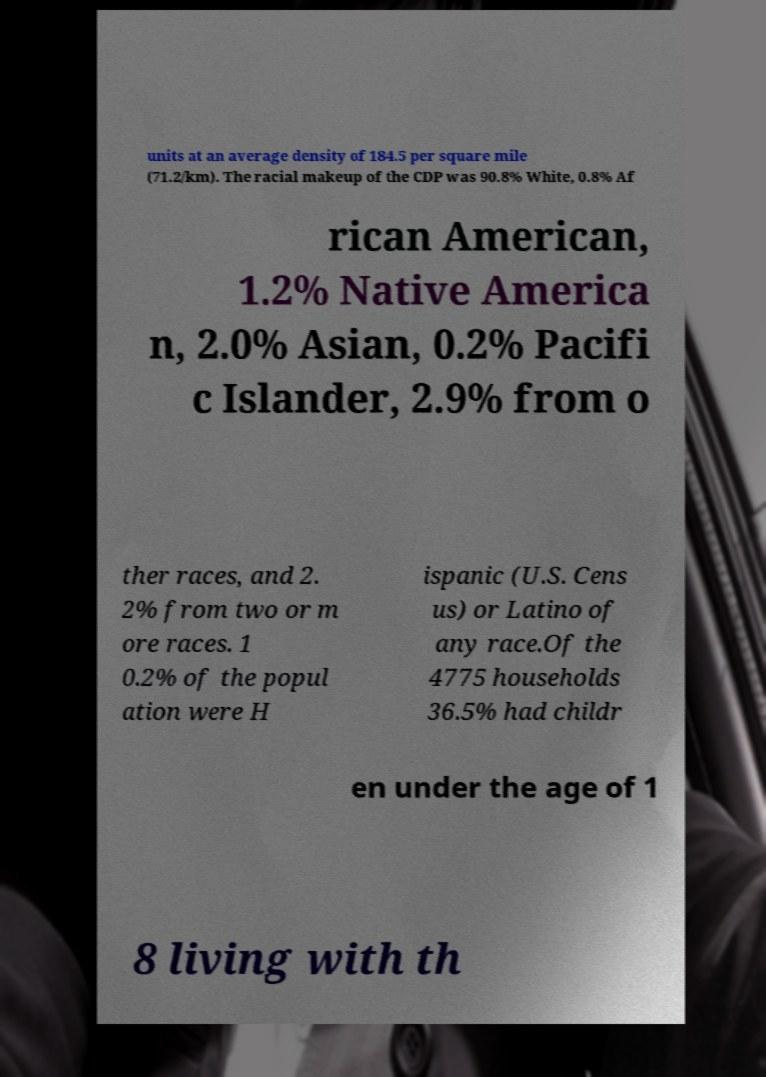Could you extract and type out the text from this image? units at an average density of 184.5 per square mile (71.2/km). The racial makeup of the CDP was 90.8% White, 0.8% Af rican American, 1.2% Native America n, 2.0% Asian, 0.2% Pacifi c Islander, 2.9% from o ther races, and 2. 2% from two or m ore races. 1 0.2% of the popul ation were H ispanic (U.S. Cens us) or Latino of any race.Of the 4775 households 36.5% had childr en under the age of 1 8 living with th 